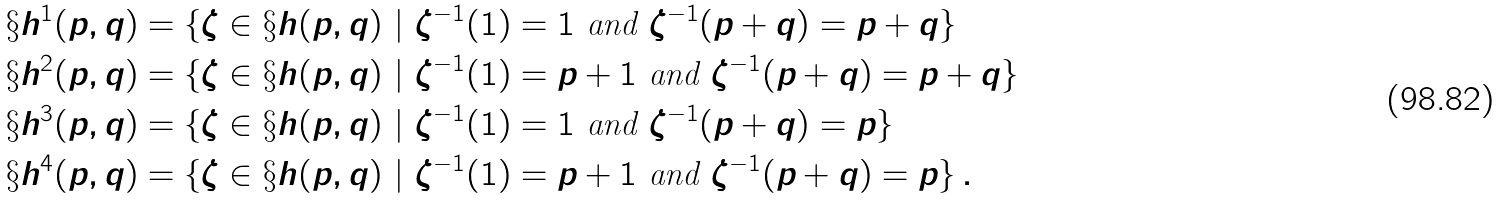<formula> <loc_0><loc_0><loc_500><loc_500>\S h ^ { 1 } ( p , q ) & = \{ \zeta \in \S h ( p , q ) \ | \ \zeta ^ { - 1 } ( 1 ) = 1 \text { and } \zeta ^ { - 1 } ( p + q ) = p + q \} \\ \S h ^ { 2 } ( p , q ) & = \{ \zeta \in \S h ( p , q ) \ | \ \zeta ^ { - 1 } ( 1 ) = p + 1 \text { and } \zeta ^ { - 1 } ( p + q ) = p + q \} \\ \S h ^ { 3 } ( p , q ) & = \{ \zeta \in \S h ( p , q ) \ | \ \zeta ^ { - 1 } ( 1 ) = 1 \text { and } \zeta ^ { - 1 } ( p + q ) = p \} \\ \S h ^ { 4 } ( p , q ) & = \{ \zeta \in \S h ( p , q ) \ | \ \zeta ^ { - 1 } ( 1 ) = p + 1 \text { and } \zeta ^ { - 1 } ( p + q ) = p \} \, .</formula> 